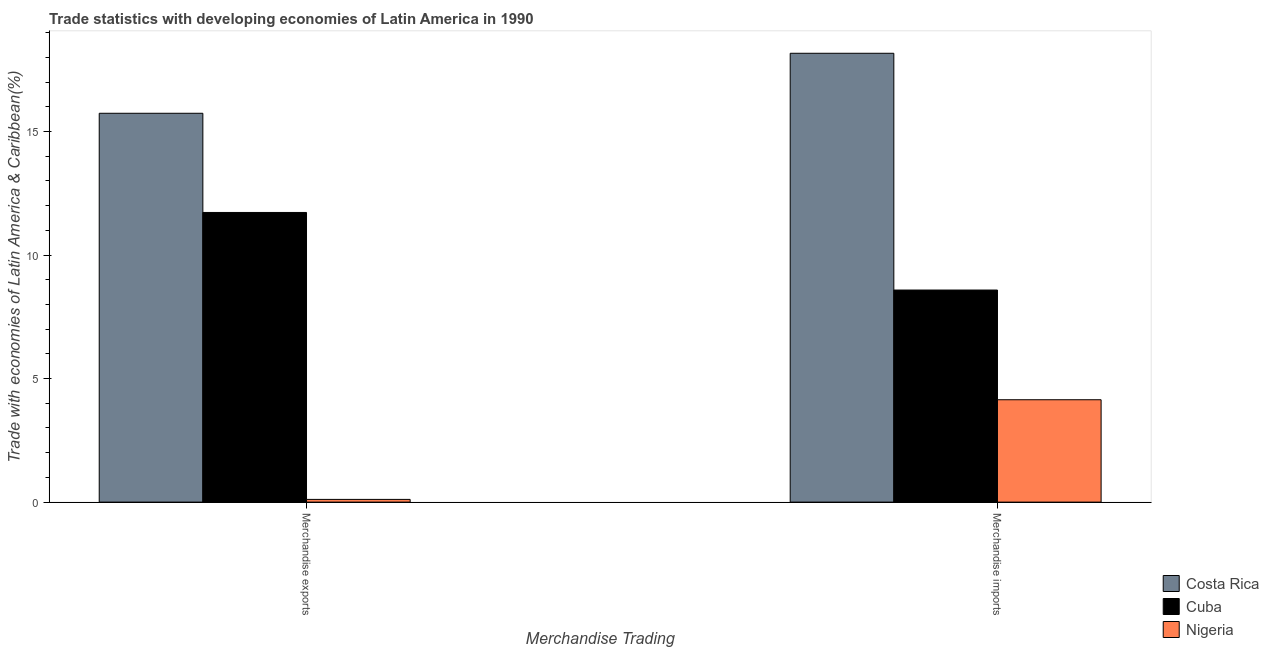Are the number of bars on each tick of the X-axis equal?
Give a very brief answer. Yes. What is the merchandise imports in Costa Rica?
Offer a very short reply. 18.16. Across all countries, what is the maximum merchandise exports?
Keep it short and to the point. 15.74. Across all countries, what is the minimum merchandise exports?
Ensure brevity in your answer.  0.11. In which country was the merchandise exports maximum?
Your answer should be very brief. Costa Rica. In which country was the merchandise imports minimum?
Offer a very short reply. Nigeria. What is the total merchandise imports in the graph?
Provide a short and direct response. 30.89. What is the difference between the merchandise exports in Costa Rica and that in Nigeria?
Your answer should be compact. 15.63. What is the difference between the merchandise imports in Nigeria and the merchandise exports in Cuba?
Give a very brief answer. -7.58. What is the average merchandise exports per country?
Make the answer very short. 9.19. What is the difference between the merchandise imports and merchandise exports in Nigeria?
Keep it short and to the point. 4.03. In how many countries, is the merchandise imports greater than 5 %?
Offer a terse response. 2. What is the ratio of the merchandise imports in Costa Rica to that in Nigeria?
Offer a very short reply. 4.38. Is the merchandise imports in Cuba less than that in Costa Rica?
Your answer should be very brief. Yes. In how many countries, is the merchandise imports greater than the average merchandise imports taken over all countries?
Your answer should be compact. 1. What does the 1st bar from the left in Merchandise imports represents?
Keep it short and to the point. Costa Rica. What does the 1st bar from the right in Merchandise exports represents?
Your answer should be very brief. Nigeria. How many bars are there?
Provide a short and direct response. 6. Are all the bars in the graph horizontal?
Give a very brief answer. No. Are the values on the major ticks of Y-axis written in scientific E-notation?
Offer a very short reply. No. Does the graph contain any zero values?
Your answer should be very brief. No. Where does the legend appear in the graph?
Provide a short and direct response. Bottom right. How are the legend labels stacked?
Your answer should be very brief. Vertical. What is the title of the graph?
Provide a succinct answer. Trade statistics with developing economies of Latin America in 1990. What is the label or title of the X-axis?
Provide a short and direct response. Merchandise Trading. What is the label or title of the Y-axis?
Offer a very short reply. Trade with economies of Latin America & Caribbean(%). What is the Trade with economies of Latin America & Caribbean(%) of Costa Rica in Merchandise exports?
Give a very brief answer. 15.74. What is the Trade with economies of Latin America & Caribbean(%) in Cuba in Merchandise exports?
Offer a terse response. 11.72. What is the Trade with economies of Latin America & Caribbean(%) in Nigeria in Merchandise exports?
Provide a short and direct response. 0.11. What is the Trade with economies of Latin America & Caribbean(%) in Costa Rica in Merchandise imports?
Your answer should be very brief. 18.16. What is the Trade with economies of Latin America & Caribbean(%) of Cuba in Merchandise imports?
Your response must be concise. 8.58. What is the Trade with economies of Latin America & Caribbean(%) in Nigeria in Merchandise imports?
Your response must be concise. 4.14. Across all Merchandise Trading, what is the maximum Trade with economies of Latin America & Caribbean(%) in Costa Rica?
Offer a very short reply. 18.16. Across all Merchandise Trading, what is the maximum Trade with economies of Latin America & Caribbean(%) in Cuba?
Offer a very short reply. 11.72. Across all Merchandise Trading, what is the maximum Trade with economies of Latin America & Caribbean(%) of Nigeria?
Ensure brevity in your answer.  4.14. Across all Merchandise Trading, what is the minimum Trade with economies of Latin America & Caribbean(%) in Costa Rica?
Provide a short and direct response. 15.74. Across all Merchandise Trading, what is the minimum Trade with economies of Latin America & Caribbean(%) in Cuba?
Your answer should be very brief. 8.58. Across all Merchandise Trading, what is the minimum Trade with economies of Latin America & Caribbean(%) of Nigeria?
Make the answer very short. 0.11. What is the total Trade with economies of Latin America & Caribbean(%) in Costa Rica in the graph?
Provide a short and direct response. 33.9. What is the total Trade with economies of Latin America & Caribbean(%) of Cuba in the graph?
Give a very brief answer. 20.3. What is the total Trade with economies of Latin America & Caribbean(%) of Nigeria in the graph?
Provide a succinct answer. 4.25. What is the difference between the Trade with economies of Latin America & Caribbean(%) in Costa Rica in Merchandise exports and that in Merchandise imports?
Offer a very short reply. -2.43. What is the difference between the Trade with economies of Latin America & Caribbean(%) of Cuba in Merchandise exports and that in Merchandise imports?
Offer a terse response. 3.14. What is the difference between the Trade with economies of Latin America & Caribbean(%) of Nigeria in Merchandise exports and that in Merchandise imports?
Keep it short and to the point. -4.03. What is the difference between the Trade with economies of Latin America & Caribbean(%) in Costa Rica in Merchandise exports and the Trade with economies of Latin America & Caribbean(%) in Cuba in Merchandise imports?
Ensure brevity in your answer.  7.15. What is the difference between the Trade with economies of Latin America & Caribbean(%) of Costa Rica in Merchandise exports and the Trade with economies of Latin America & Caribbean(%) of Nigeria in Merchandise imports?
Offer a very short reply. 11.59. What is the difference between the Trade with economies of Latin America & Caribbean(%) in Cuba in Merchandise exports and the Trade with economies of Latin America & Caribbean(%) in Nigeria in Merchandise imports?
Ensure brevity in your answer.  7.58. What is the average Trade with economies of Latin America & Caribbean(%) of Costa Rica per Merchandise Trading?
Your answer should be very brief. 16.95. What is the average Trade with economies of Latin America & Caribbean(%) of Cuba per Merchandise Trading?
Ensure brevity in your answer.  10.15. What is the average Trade with economies of Latin America & Caribbean(%) of Nigeria per Merchandise Trading?
Offer a terse response. 2.13. What is the difference between the Trade with economies of Latin America & Caribbean(%) in Costa Rica and Trade with economies of Latin America & Caribbean(%) in Cuba in Merchandise exports?
Your answer should be compact. 4.01. What is the difference between the Trade with economies of Latin America & Caribbean(%) of Costa Rica and Trade with economies of Latin America & Caribbean(%) of Nigeria in Merchandise exports?
Offer a very short reply. 15.63. What is the difference between the Trade with economies of Latin America & Caribbean(%) of Cuba and Trade with economies of Latin America & Caribbean(%) of Nigeria in Merchandise exports?
Ensure brevity in your answer.  11.61. What is the difference between the Trade with economies of Latin America & Caribbean(%) in Costa Rica and Trade with economies of Latin America & Caribbean(%) in Cuba in Merchandise imports?
Ensure brevity in your answer.  9.58. What is the difference between the Trade with economies of Latin America & Caribbean(%) in Costa Rica and Trade with economies of Latin America & Caribbean(%) in Nigeria in Merchandise imports?
Your answer should be compact. 14.02. What is the difference between the Trade with economies of Latin America & Caribbean(%) in Cuba and Trade with economies of Latin America & Caribbean(%) in Nigeria in Merchandise imports?
Give a very brief answer. 4.44. What is the ratio of the Trade with economies of Latin America & Caribbean(%) in Costa Rica in Merchandise exports to that in Merchandise imports?
Ensure brevity in your answer.  0.87. What is the ratio of the Trade with economies of Latin America & Caribbean(%) in Cuba in Merchandise exports to that in Merchandise imports?
Keep it short and to the point. 1.37. What is the ratio of the Trade with economies of Latin America & Caribbean(%) of Nigeria in Merchandise exports to that in Merchandise imports?
Give a very brief answer. 0.03. What is the difference between the highest and the second highest Trade with economies of Latin America & Caribbean(%) of Costa Rica?
Keep it short and to the point. 2.43. What is the difference between the highest and the second highest Trade with economies of Latin America & Caribbean(%) in Cuba?
Keep it short and to the point. 3.14. What is the difference between the highest and the second highest Trade with economies of Latin America & Caribbean(%) of Nigeria?
Offer a very short reply. 4.03. What is the difference between the highest and the lowest Trade with economies of Latin America & Caribbean(%) in Costa Rica?
Offer a very short reply. 2.43. What is the difference between the highest and the lowest Trade with economies of Latin America & Caribbean(%) of Cuba?
Provide a short and direct response. 3.14. What is the difference between the highest and the lowest Trade with economies of Latin America & Caribbean(%) in Nigeria?
Your answer should be compact. 4.03. 